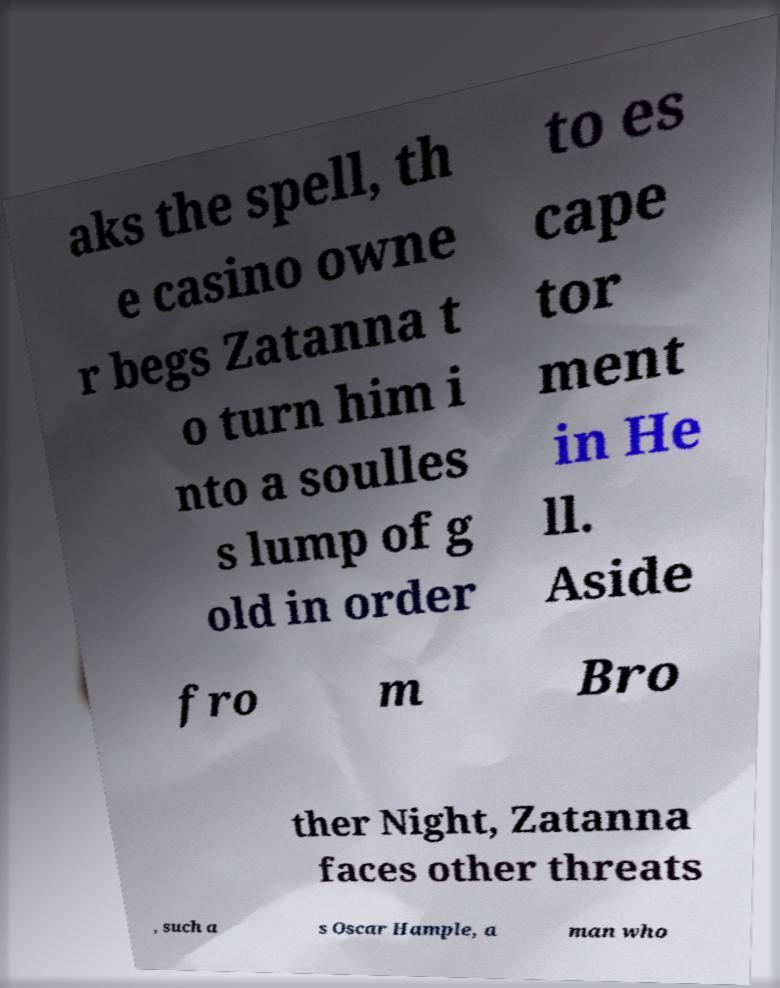Could you assist in decoding the text presented in this image and type it out clearly? aks the spell, th e casino owne r begs Zatanna t o turn him i nto a soulles s lump of g old in order to es cape tor ment in He ll. Aside fro m Bro ther Night, Zatanna faces other threats , such a s Oscar Hample, a man who 